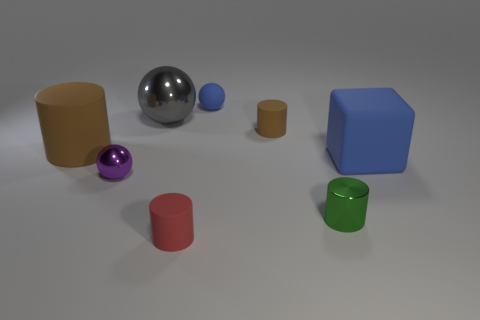Is the matte cube the same color as the rubber sphere?
Offer a terse response. Yes. Do the sphere on the right side of the gray metallic sphere and the block have the same color?
Make the answer very short. Yes. There is a large cube; does it have the same color as the tiny sphere behind the big blue thing?
Provide a succinct answer. Yes. There is a sphere that is both behind the purple object and in front of the small blue matte sphere; what size is it?
Your answer should be compact. Large. How many other objects are there of the same color as the matte block?
Offer a terse response. 1. There is a brown cylinder to the left of the purple thing behind the small red object in front of the blue rubber block; what is its size?
Offer a terse response. Large. There is a tiny green object; are there any blue matte cubes in front of it?
Make the answer very short. No. Does the matte sphere have the same size as the matte cylinder that is on the left side of the large shiny sphere?
Keep it short and to the point. No. How many other things are the same material as the gray thing?
Your answer should be compact. 2. The thing that is behind the purple ball and on the right side of the small brown rubber cylinder has what shape?
Make the answer very short. Cube. 